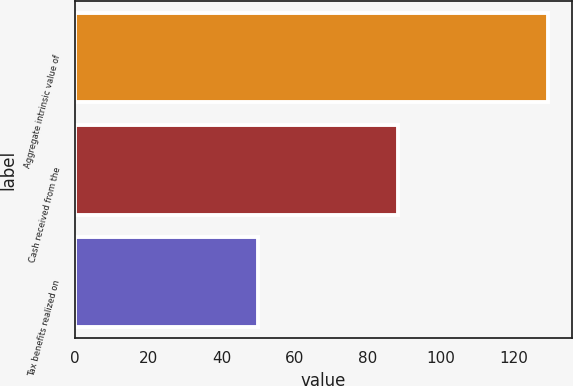Convert chart to OTSL. <chart><loc_0><loc_0><loc_500><loc_500><bar_chart><fcel>Aggregate intrinsic value of<fcel>Cash received from the<fcel>Tax benefits realized on<nl><fcel>129.4<fcel>88.3<fcel>50<nl></chart> 